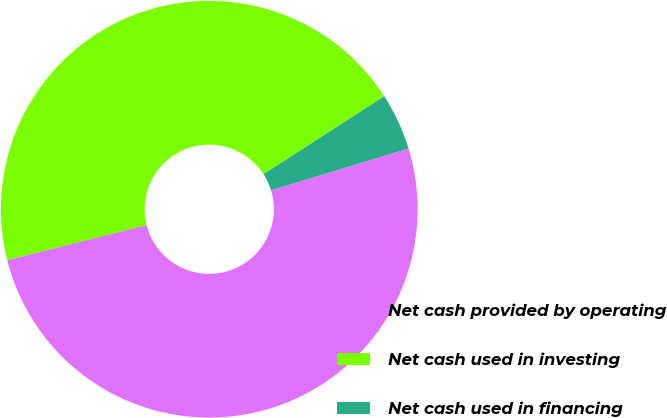Convert chart to OTSL. <chart><loc_0><loc_0><loc_500><loc_500><pie_chart><fcel>Net cash provided by operating<fcel>Net cash used in investing<fcel>Net cash used in financing<nl><fcel>50.78%<fcel>44.81%<fcel>4.41%<nl></chart> 